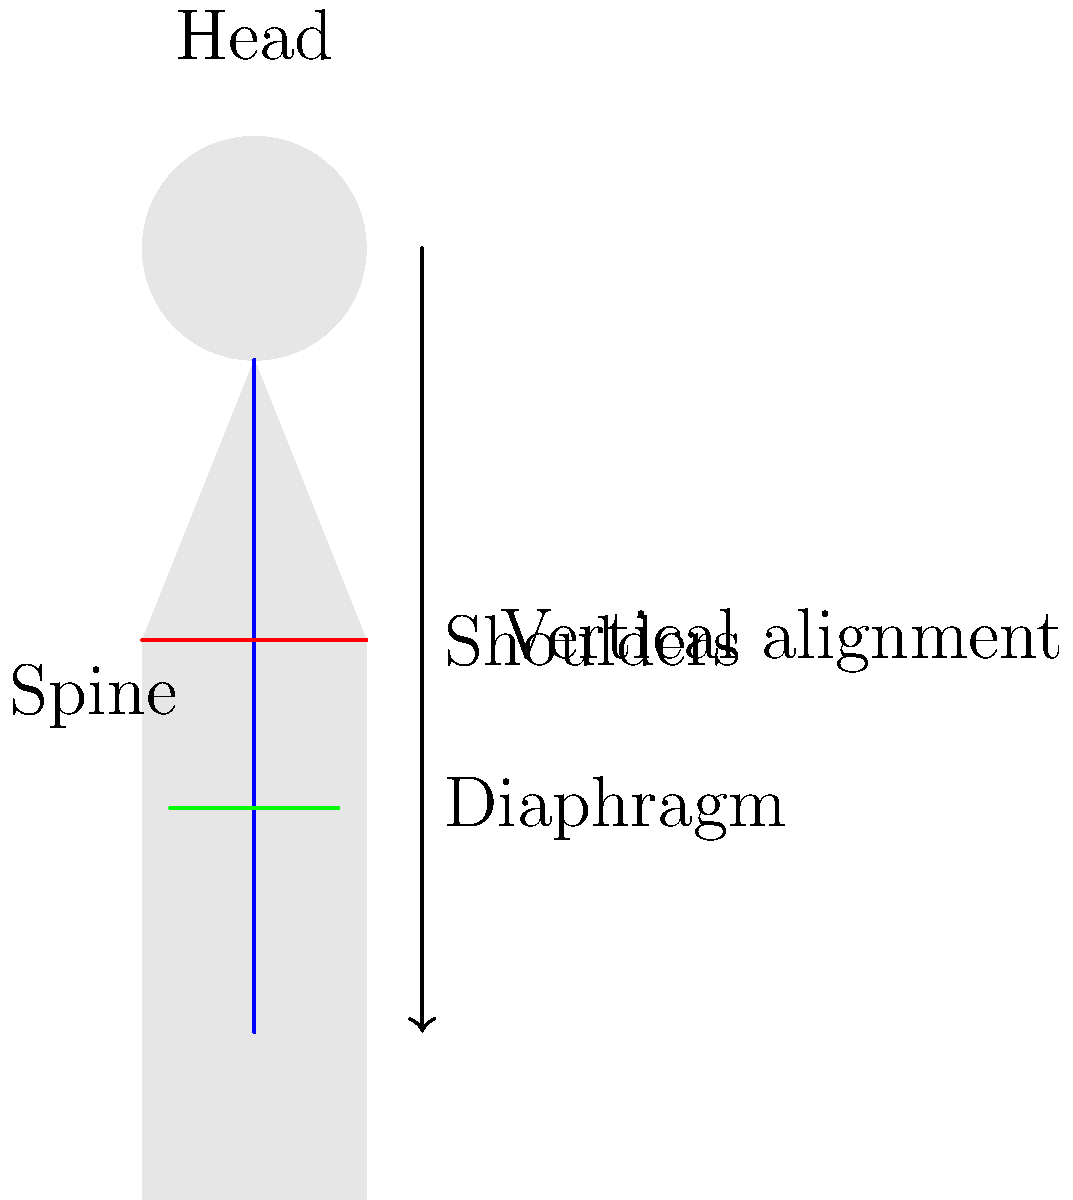In the context of proper singing posture, particularly important for yodeling in classic country music, which of the following statements is most accurate regarding the alignment of the body?

A) The head should be tilted slightly forward for better projection
B) The shoulders should be raised to support the diaphragm
C) The spine should be curved to create more resonance space
D) The body should maintain a vertical alignment from head to feet To understand the correct posture for singing, especially for techniques like yodeling in classic country music, we need to consider the biomechanics of the human body:

1. Vertical Alignment: The key to proper singing posture is maintaining a vertical alignment from the head through the spine to the feet. This allows for optimal breath support and vocal cord function.

2. Head Position: The head should be balanced on top of the spine, neither tilted forward nor backward. This neutral position allows for free movement of the larynx and proper resonance.

3. Shoulders: They should be relaxed and in a neutral position, neither raised nor hunched forward. Raised shoulders can create tension that interferes with breathing and vocal production.

4. Spine: A straight, but not rigid, spine allows for proper breath support from the diaphragm. A curved spine can restrict breathing and affect sound quality.

5. Diaphragm: With proper vertical alignment, the diaphragm can move freely, allowing for better breath control, which is crucial for techniques like yodeling.

Given these factors, the most accurate statement is that the body should maintain a vertical alignment from head to feet. This posture allows for optimal breath support, vocal cord function, and the free movement necessary for advanced techniques like yodeling in classic country music.
Answer: D) The body should maintain a vertical alignment from head to feet 